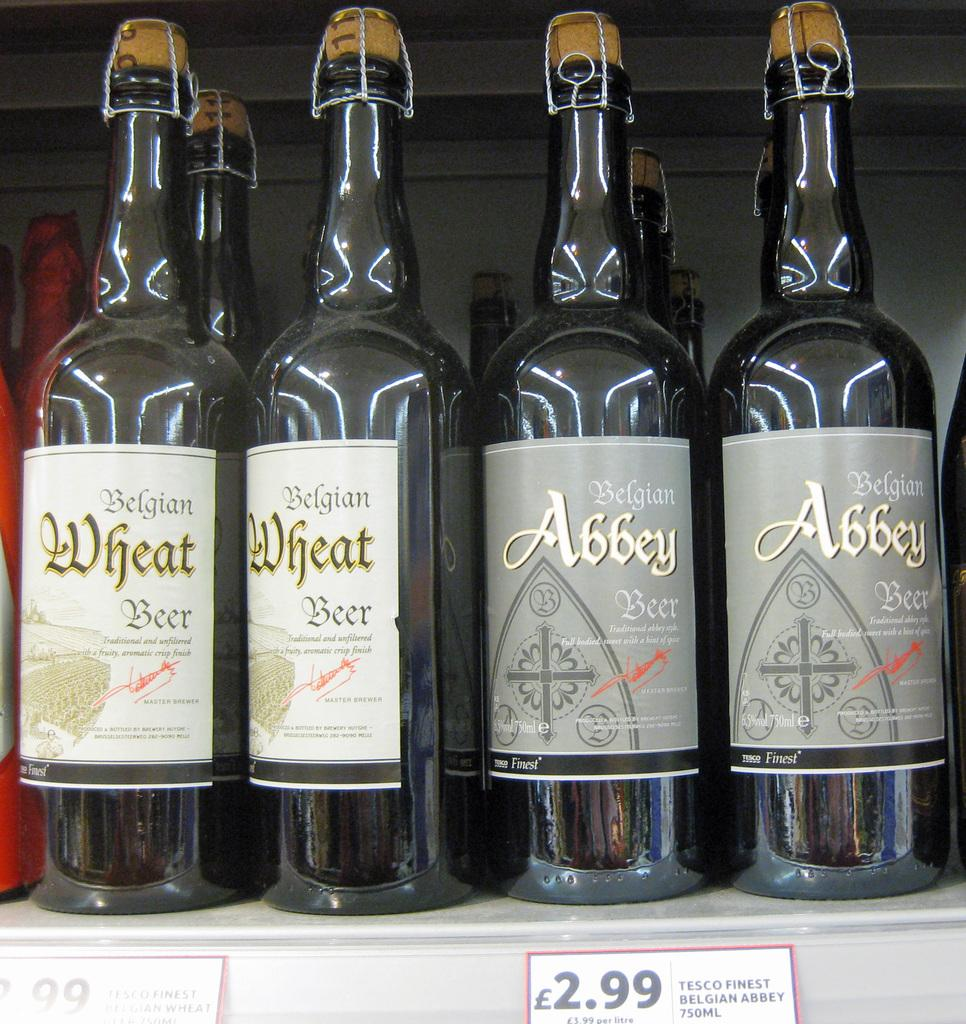What objects are present in the image in a group? There is a bunch of bottles in the image. Where are the bottles located? The bottles are on a shelf. What type of land can be seen in the image? There is no land visible in the image, as it features a bunch of bottles on a shelf. What is the cap used for in the image? There is no cap present in the image; it only shows a bunch of bottles on a shelf. 